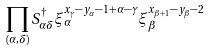Convert formula to latex. <formula><loc_0><loc_0><loc_500><loc_500>\prod _ { ( \alpha , \delta ) } S _ { \alpha \delta } ^ { \dag } \xi _ { \alpha } ^ { x _ { \gamma } - y _ { \alpha } - 1 + \alpha - \gamma } \xi _ { \beta } ^ { x _ { \beta + 1 } - y _ { \beta } - 2 }</formula> 